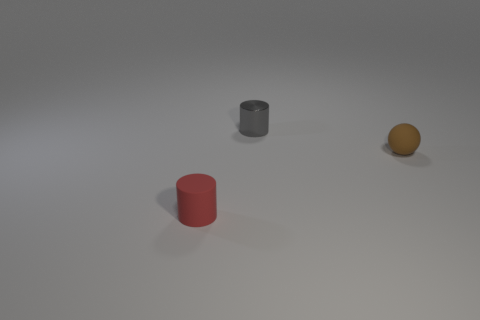Is there anything else that is the same material as the small gray cylinder?
Offer a terse response. No. There is a tiny rubber object that is in front of the sphere; what number of small objects are behind it?
Keep it short and to the point. 2. What number of other objects are the same material as the small ball?
Your answer should be compact. 1. Are the tiny object behind the small ball and the small object in front of the brown sphere made of the same material?
Your answer should be very brief. No. Is there anything else that has the same shape as the red object?
Offer a terse response. Yes. Does the brown ball have the same material as the cylinder that is on the left side of the gray thing?
Provide a succinct answer. Yes. There is a small rubber object on the left side of the rubber thing right of the small rubber object that is on the left side of the small brown matte object; what is its color?
Make the answer very short. Red. What is the shape of the brown thing that is the same size as the red thing?
Your response must be concise. Sphere. Is there any other thing that has the same size as the metal object?
Your response must be concise. Yes. Is the size of the object in front of the brown ball the same as the rubber thing that is to the right of the tiny metal cylinder?
Offer a very short reply. Yes. 